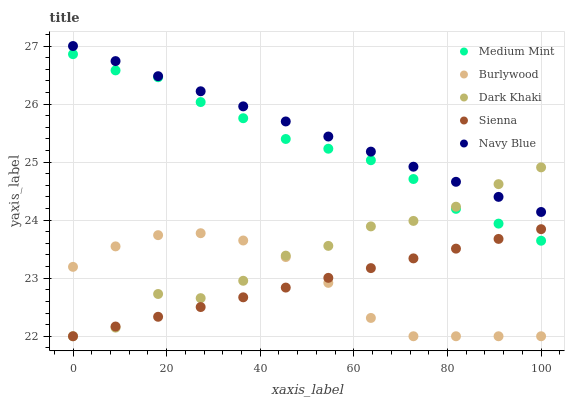Does Burlywood have the minimum area under the curve?
Answer yes or no. Yes. Does Navy Blue have the maximum area under the curve?
Answer yes or no. Yes. Does Navy Blue have the minimum area under the curve?
Answer yes or no. No. Does Burlywood have the maximum area under the curve?
Answer yes or no. No. Is Navy Blue the smoothest?
Answer yes or no. Yes. Is Dark Khaki the roughest?
Answer yes or no. Yes. Is Burlywood the smoothest?
Answer yes or no. No. Is Burlywood the roughest?
Answer yes or no. No. Does Burlywood have the lowest value?
Answer yes or no. Yes. Does Navy Blue have the lowest value?
Answer yes or no. No. Does Navy Blue have the highest value?
Answer yes or no. Yes. Does Burlywood have the highest value?
Answer yes or no. No. Is Medium Mint less than Navy Blue?
Answer yes or no. Yes. Is Medium Mint greater than Burlywood?
Answer yes or no. Yes. Does Medium Mint intersect Dark Khaki?
Answer yes or no. Yes. Is Medium Mint less than Dark Khaki?
Answer yes or no. No. Is Medium Mint greater than Dark Khaki?
Answer yes or no. No. Does Medium Mint intersect Navy Blue?
Answer yes or no. No. 